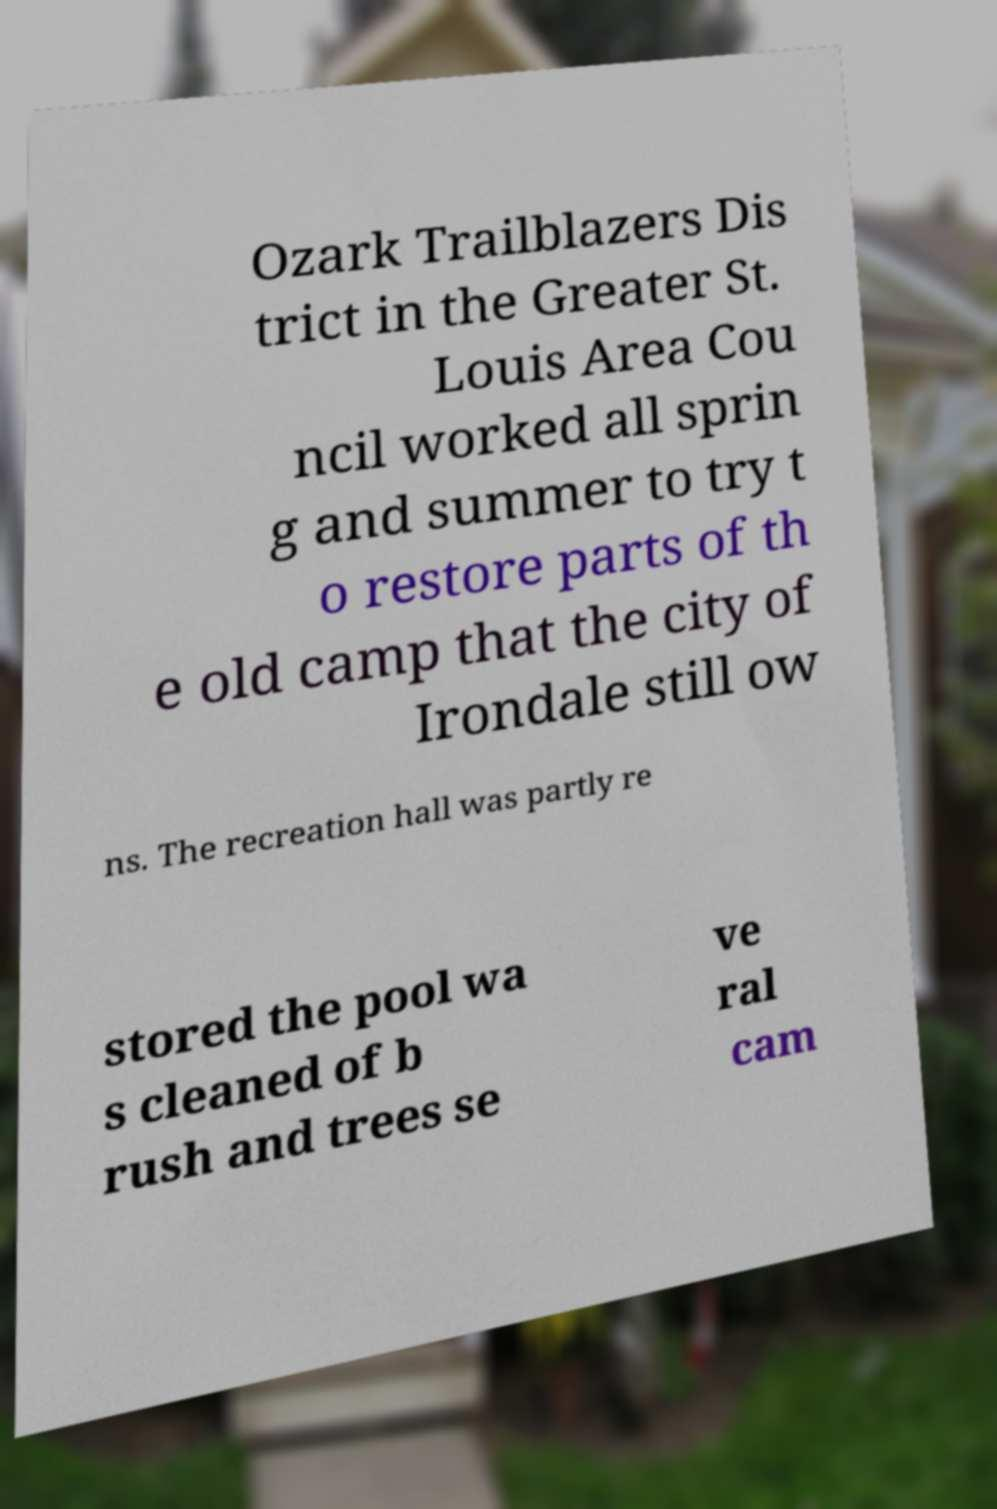There's text embedded in this image that I need extracted. Can you transcribe it verbatim? Ozark Trailblazers Dis trict in the Greater St. Louis Area Cou ncil worked all sprin g and summer to try t o restore parts of th e old camp that the city of Irondale still ow ns. The recreation hall was partly re stored the pool wa s cleaned of b rush and trees se ve ral cam 